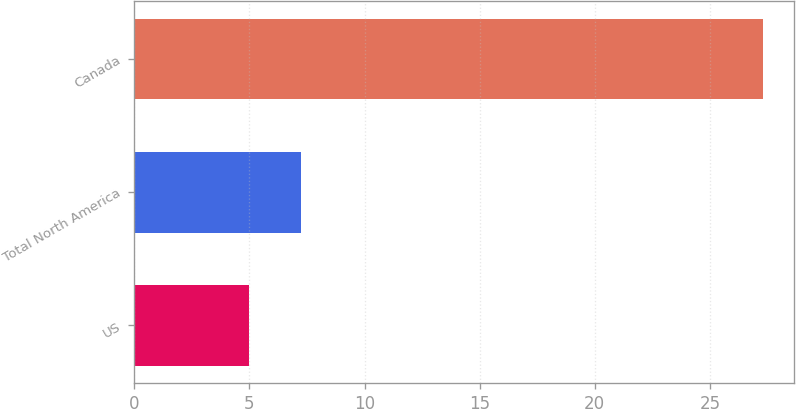Convert chart. <chart><loc_0><loc_0><loc_500><loc_500><bar_chart><fcel>US<fcel>Total North America<fcel>Canada<nl><fcel>5<fcel>7.23<fcel>27.3<nl></chart> 